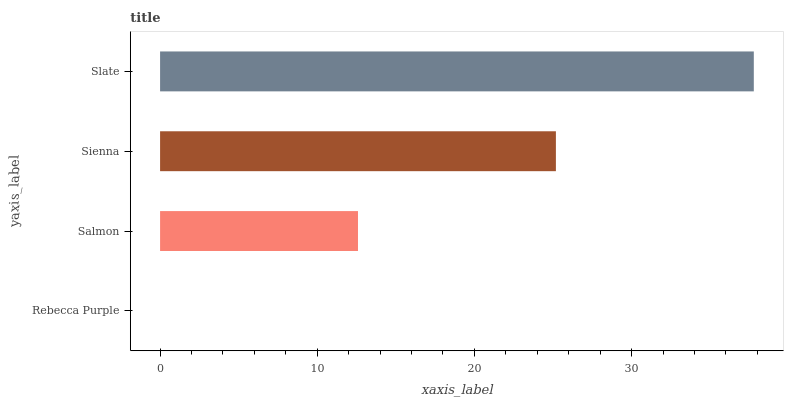Is Rebecca Purple the minimum?
Answer yes or no. Yes. Is Slate the maximum?
Answer yes or no. Yes. Is Salmon the minimum?
Answer yes or no. No. Is Salmon the maximum?
Answer yes or no. No. Is Salmon greater than Rebecca Purple?
Answer yes or no. Yes. Is Rebecca Purple less than Salmon?
Answer yes or no. Yes. Is Rebecca Purple greater than Salmon?
Answer yes or no. No. Is Salmon less than Rebecca Purple?
Answer yes or no. No. Is Sienna the high median?
Answer yes or no. Yes. Is Salmon the low median?
Answer yes or no. Yes. Is Slate the high median?
Answer yes or no. No. Is Rebecca Purple the low median?
Answer yes or no. No. 